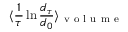Convert formula to latex. <formula><loc_0><loc_0><loc_500><loc_500>\langle \frac { 1 } { \tau } \ln \frac { d _ { \tau } } { d _ { 0 } } \rangle _ { v o l u m e }</formula> 